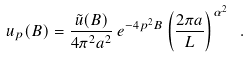<formula> <loc_0><loc_0><loc_500><loc_500>u _ { p } ( B ) = \frac { \tilde { u } ( B ) } { 4 \pi ^ { 2 } a ^ { 2 } } \, e ^ { - 4 p ^ { 2 } B } \left ( \frac { 2 \pi a } { L } \right ) ^ { \alpha ^ { 2 } } \ .</formula> 